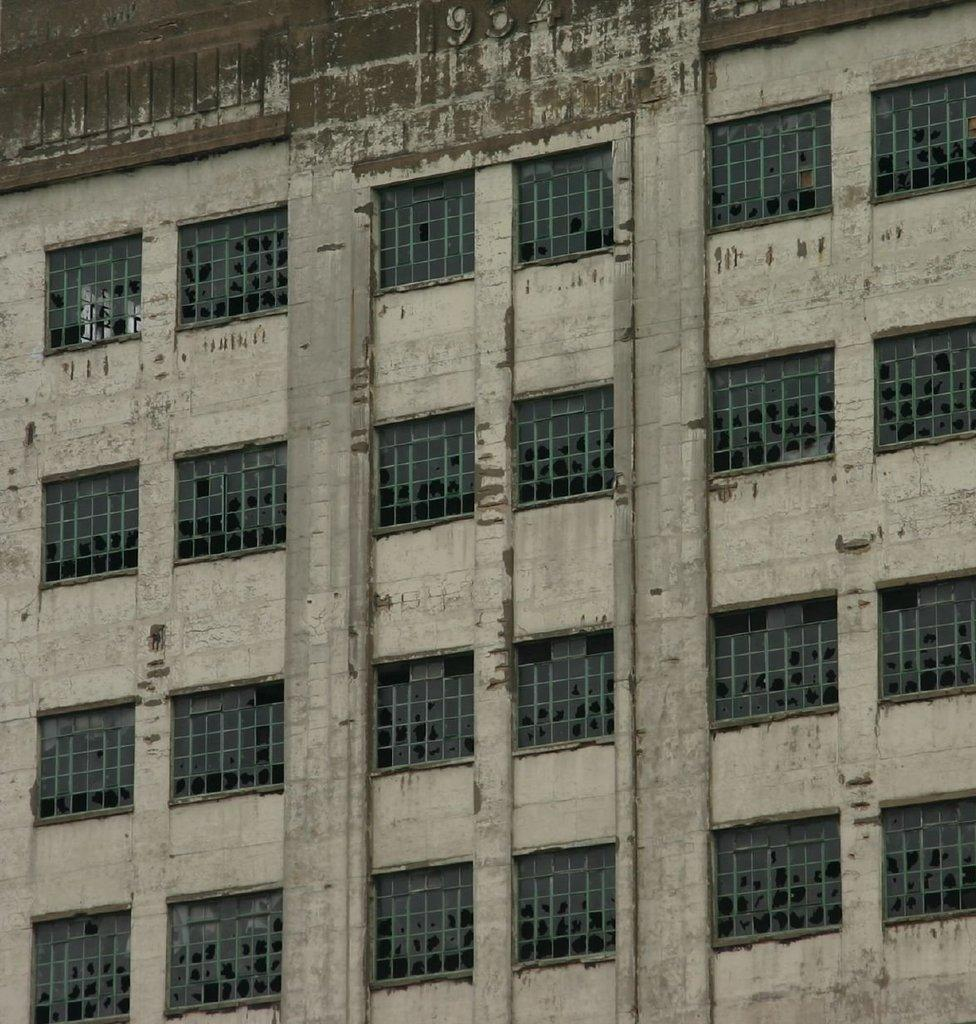What is the main structure in the image? There is a building in the image. What architectural features can be seen on the building? The building has windows and pillars. What type of eggnog is being served in the building in the image? There is no eggnog present in the image, as it only features a building with windows and pillars. 